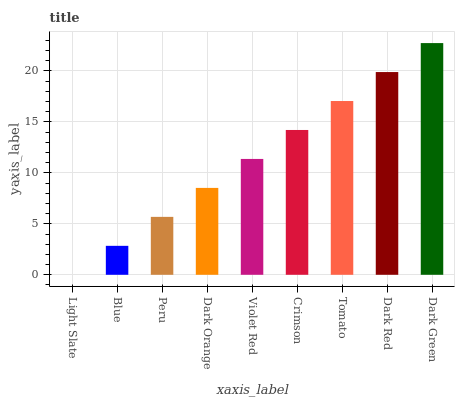Is Light Slate the minimum?
Answer yes or no. Yes. Is Dark Green the maximum?
Answer yes or no. Yes. Is Blue the minimum?
Answer yes or no. No. Is Blue the maximum?
Answer yes or no. No. Is Blue greater than Light Slate?
Answer yes or no. Yes. Is Light Slate less than Blue?
Answer yes or no. Yes. Is Light Slate greater than Blue?
Answer yes or no. No. Is Blue less than Light Slate?
Answer yes or no. No. Is Violet Red the high median?
Answer yes or no. Yes. Is Violet Red the low median?
Answer yes or no. Yes. Is Light Slate the high median?
Answer yes or no. No. Is Dark Green the low median?
Answer yes or no. No. 